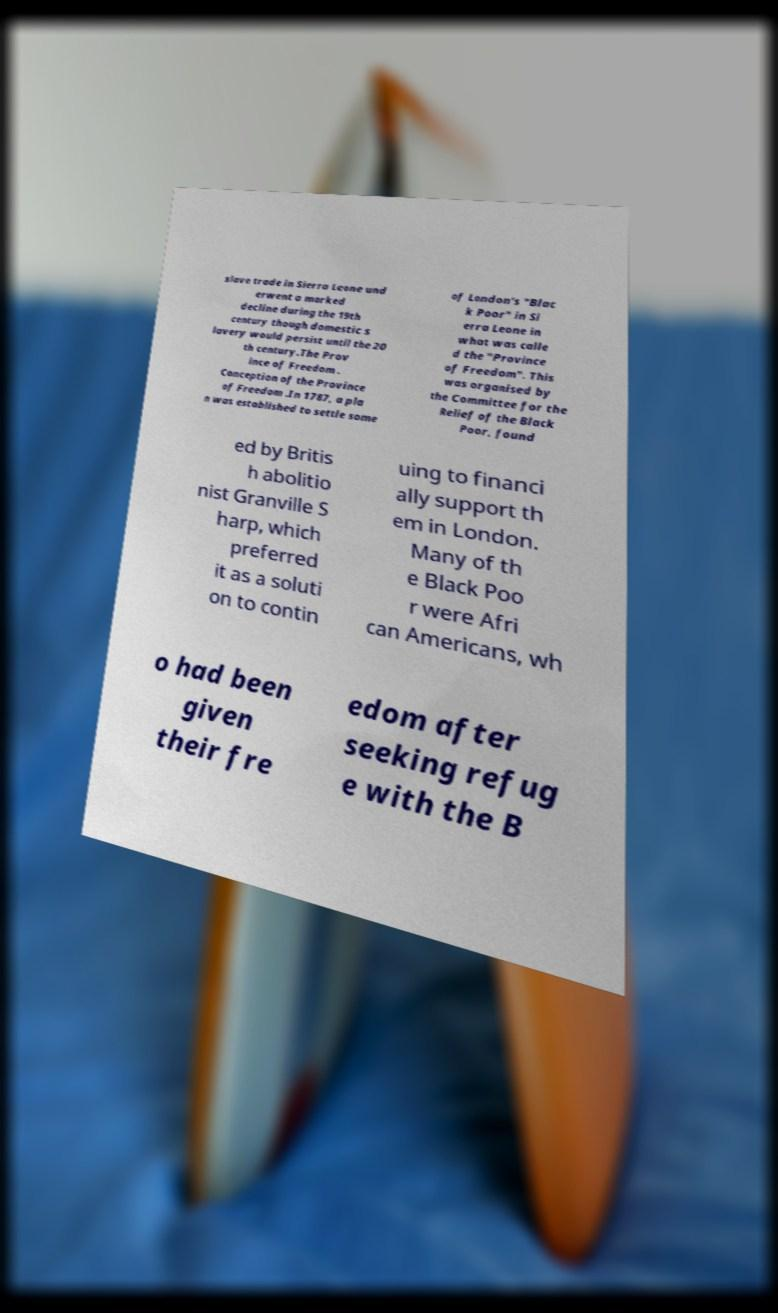Can you accurately transcribe the text from the provided image for me? slave trade in Sierra Leone und erwent a marked decline during the 19th century though domestic s lavery would persist until the 20 th century.The Prov ince of Freedom . Conception of the Province of Freedom .In 1787, a pla n was established to settle some of London's "Blac k Poor" in Si erra Leone in what was calle d the "Province of Freedom". This was organised by the Committee for the Relief of the Black Poor, found ed by Britis h abolitio nist Granville S harp, which preferred it as a soluti on to contin uing to financi ally support th em in London. Many of th e Black Poo r were Afri can Americans, wh o had been given their fre edom after seeking refug e with the B 